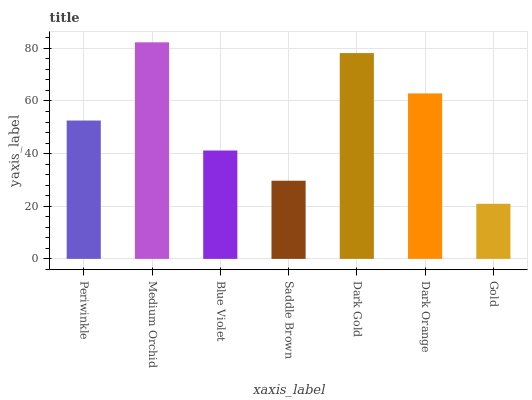Is Blue Violet the minimum?
Answer yes or no. No. Is Blue Violet the maximum?
Answer yes or no. No. Is Medium Orchid greater than Blue Violet?
Answer yes or no. Yes. Is Blue Violet less than Medium Orchid?
Answer yes or no. Yes. Is Blue Violet greater than Medium Orchid?
Answer yes or no. No. Is Medium Orchid less than Blue Violet?
Answer yes or no. No. Is Periwinkle the high median?
Answer yes or no. Yes. Is Periwinkle the low median?
Answer yes or no. Yes. Is Dark Orange the high median?
Answer yes or no. No. Is Dark Orange the low median?
Answer yes or no. No. 